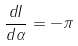Convert formula to latex. <formula><loc_0><loc_0><loc_500><loc_500>\frac { d I } { d \alpha } = - \pi</formula> 